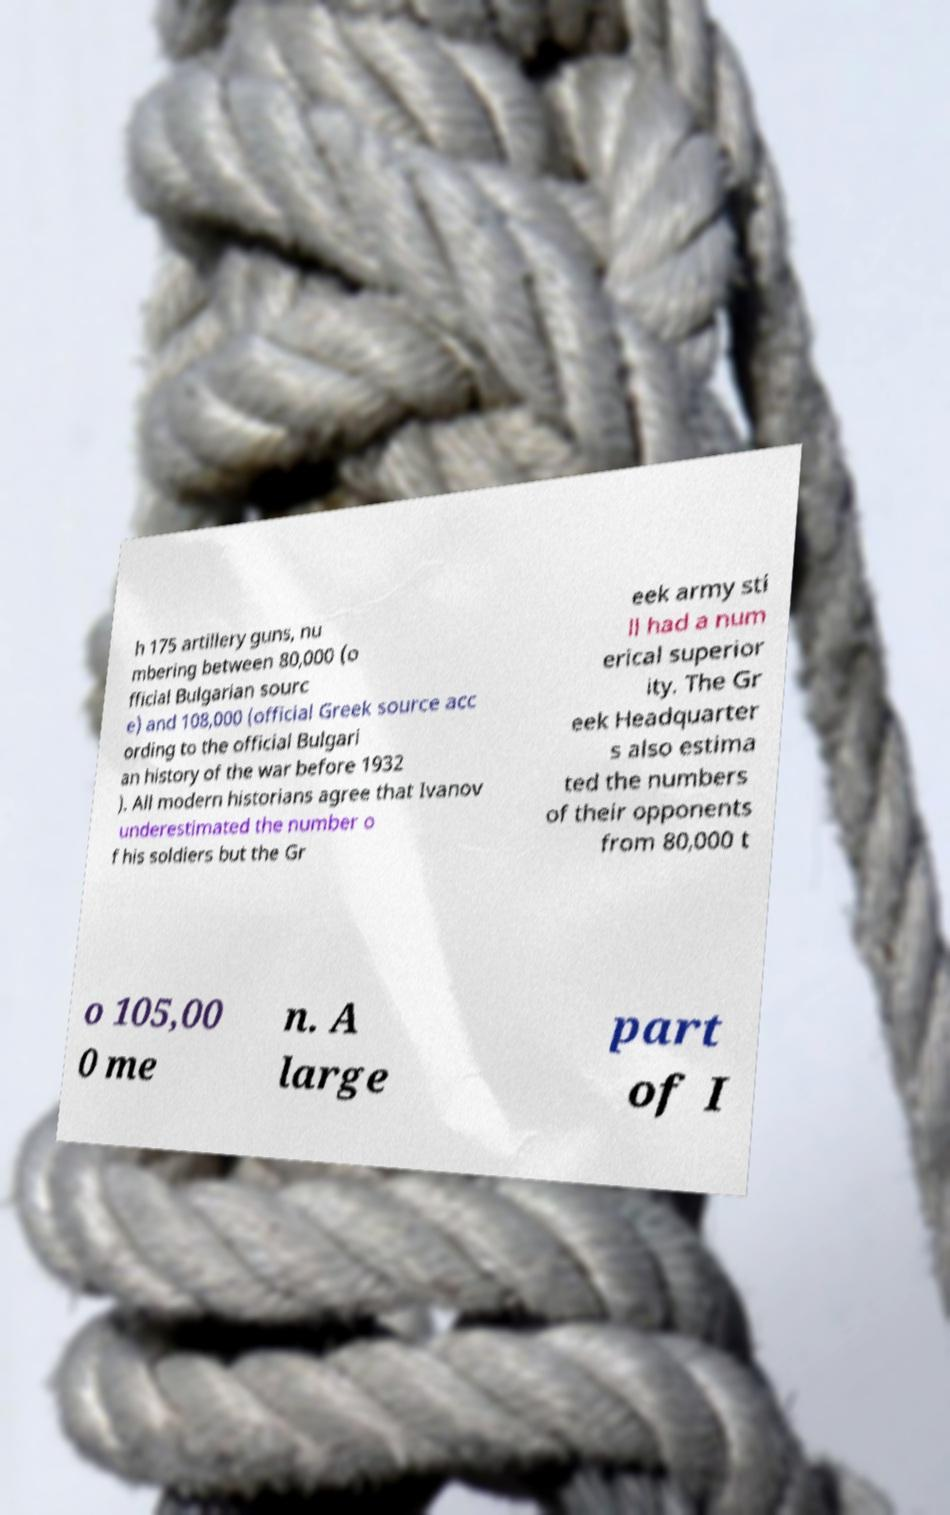What messages or text are displayed in this image? I need them in a readable, typed format. h 175 artillery guns, nu mbering between 80,000 (o fficial Bulgarian sourc e) and 108,000 (official Greek source acc ording to the official Bulgari an history of the war before 1932 ). All modern historians agree that Ivanov underestimated the number o f his soldiers but the Gr eek army sti ll had a num erical superior ity. The Gr eek Headquarter s also estima ted the numbers of their opponents from 80,000 t o 105,00 0 me n. A large part of I 